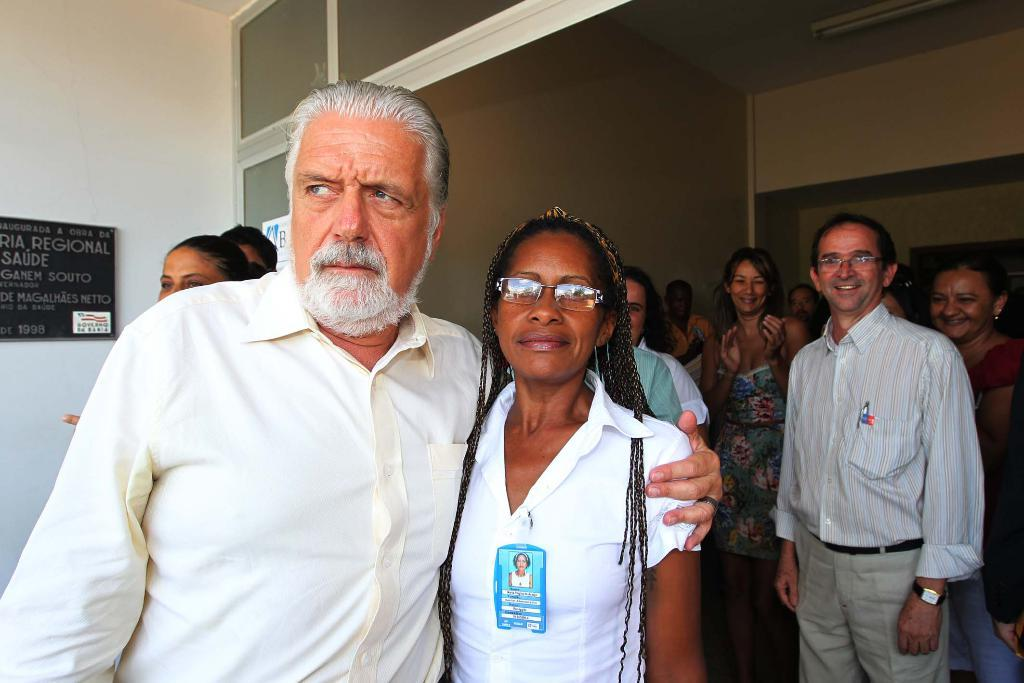What is the color of the wall in the image? The wall in the image is white. What object can be seen on the wall? There is a marble board on the wall. How many people are in the image? There are people in the image. Can you describe the position of the two persons in the front? The two persons in the front are standing. What color are the dresses worn by the two persons in the front? The two persons in the front are wearing white color dresses. What type of bell can be heard ringing in the image? There is no bell present in the image, so it is not possible to hear it ringing. 